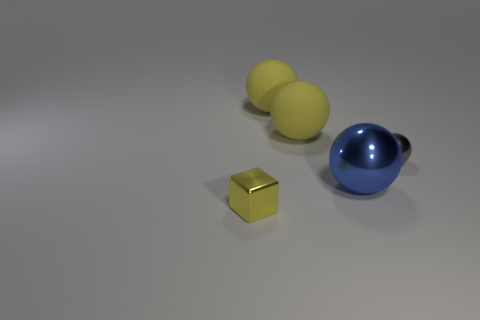Are there any other things that are made of the same material as the blue object?
Provide a short and direct response. Yes. There is a small thing left of the tiny sphere; is it the same shape as the gray metal object?
Ensure brevity in your answer.  No. What is the gray ball made of?
Your answer should be very brief. Metal. There is a small metallic thing to the right of the big ball in front of the gray thing right of the blue shiny sphere; what shape is it?
Make the answer very short. Sphere. How many other things are there of the same shape as the gray shiny object?
Offer a very short reply. 3. What number of tiny green metallic objects are there?
Offer a terse response. 0. How many objects are small yellow metal things or small cyan shiny balls?
Give a very brief answer. 1. Are there any gray spheres on the right side of the small gray thing?
Offer a very short reply. No. Are there more tiny gray balls on the left side of the blue shiny ball than tiny blocks to the left of the small yellow object?
Give a very brief answer. No. There is another metal thing that is the same shape as the blue shiny object; what size is it?
Your answer should be compact. Small. 